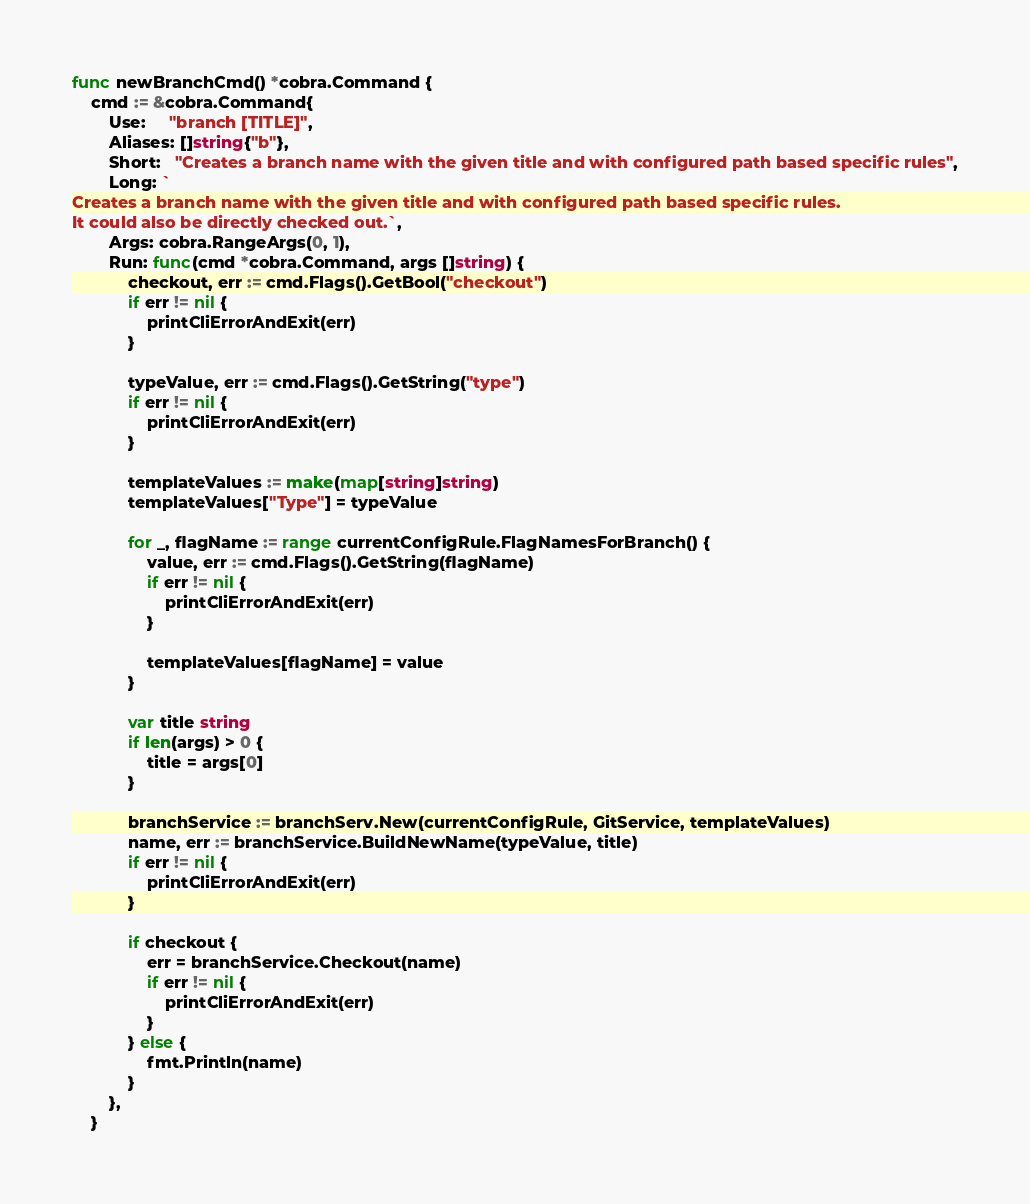<code> <loc_0><loc_0><loc_500><loc_500><_Go_>func newBranchCmd() *cobra.Command {
	cmd := &cobra.Command{
		Use:     "branch [TITLE]",
		Aliases: []string{"b"},
		Short:   "Creates a branch name with the given title and with configured path based specific rules",
		Long: `
Creates a branch name with the given title and with configured path based specific rules.
It could also be directly checked out.`,
		Args: cobra.RangeArgs(0, 1),
		Run: func(cmd *cobra.Command, args []string) {
			checkout, err := cmd.Flags().GetBool("checkout")
			if err != nil {
				printCliErrorAndExit(err)
			}

			typeValue, err := cmd.Flags().GetString("type")
			if err != nil {
				printCliErrorAndExit(err)
			}

			templateValues := make(map[string]string)
			templateValues["Type"] = typeValue

			for _, flagName := range currentConfigRule.FlagNamesForBranch() {
				value, err := cmd.Flags().GetString(flagName)
				if err != nil {
					printCliErrorAndExit(err)
				}

				templateValues[flagName] = value
			}

			var title string
			if len(args) > 0 {
				title = args[0]
			}

			branchService := branchServ.New(currentConfigRule, GitService, templateValues)
			name, err := branchService.BuildNewName(typeValue, title)
			if err != nil {
				printCliErrorAndExit(err)
			}

			if checkout {
				err = branchService.Checkout(name)
				if err != nil {
					printCliErrorAndExit(err)
				}
			} else {
				fmt.Println(name)
			}
		},
	}
</code> 